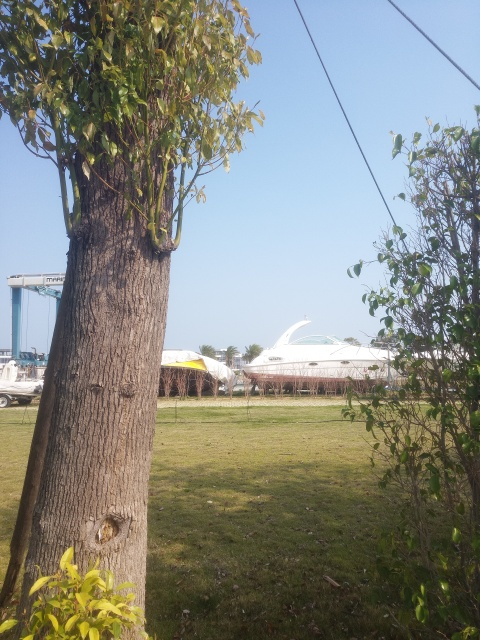What activities might be typical in this location? Given the presence of the yacht and the coastal setting, common activities might include boating, picnicking, and leisurely strolls along the shore. The surrounding open spaces may also be suitable for gatherings or events. 